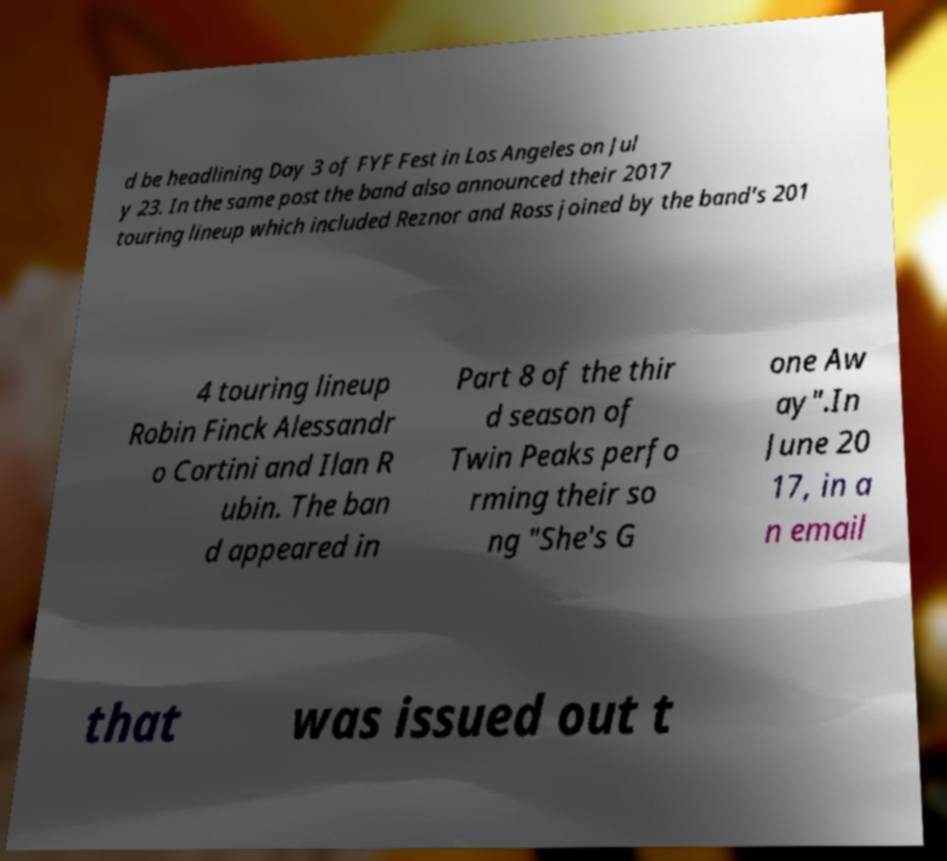What messages or text are displayed in this image? I need them in a readable, typed format. d be headlining Day 3 of FYF Fest in Los Angeles on Jul y 23. In the same post the band also announced their 2017 touring lineup which included Reznor and Ross joined by the band's 201 4 touring lineup Robin Finck Alessandr o Cortini and Ilan R ubin. The ban d appeared in Part 8 of the thir d season of Twin Peaks perfo rming their so ng "She's G one Aw ay".In June 20 17, in a n email that was issued out t 